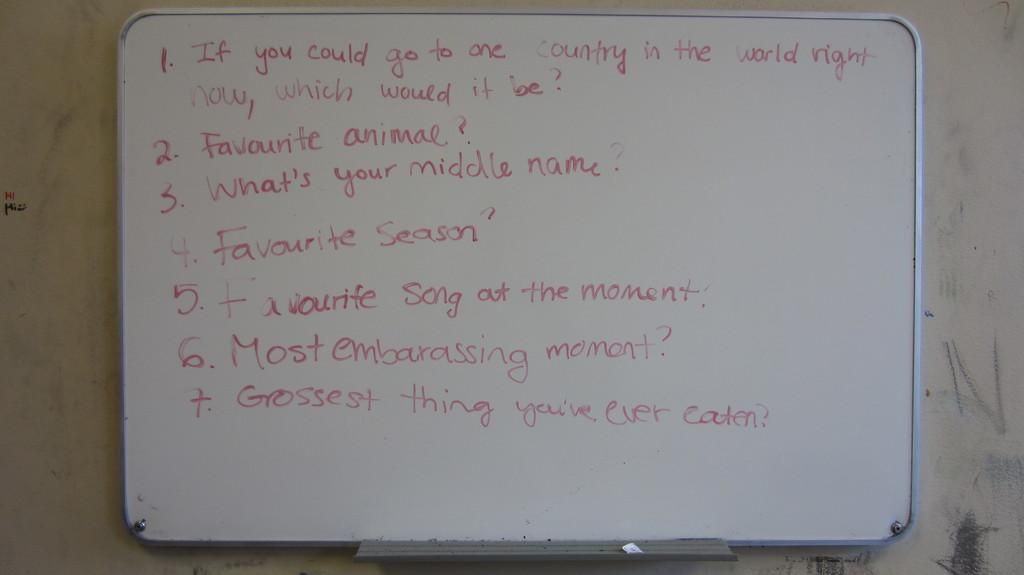<image>
Write a terse but informative summary of the picture. A white board with 7 different questions asked on them 